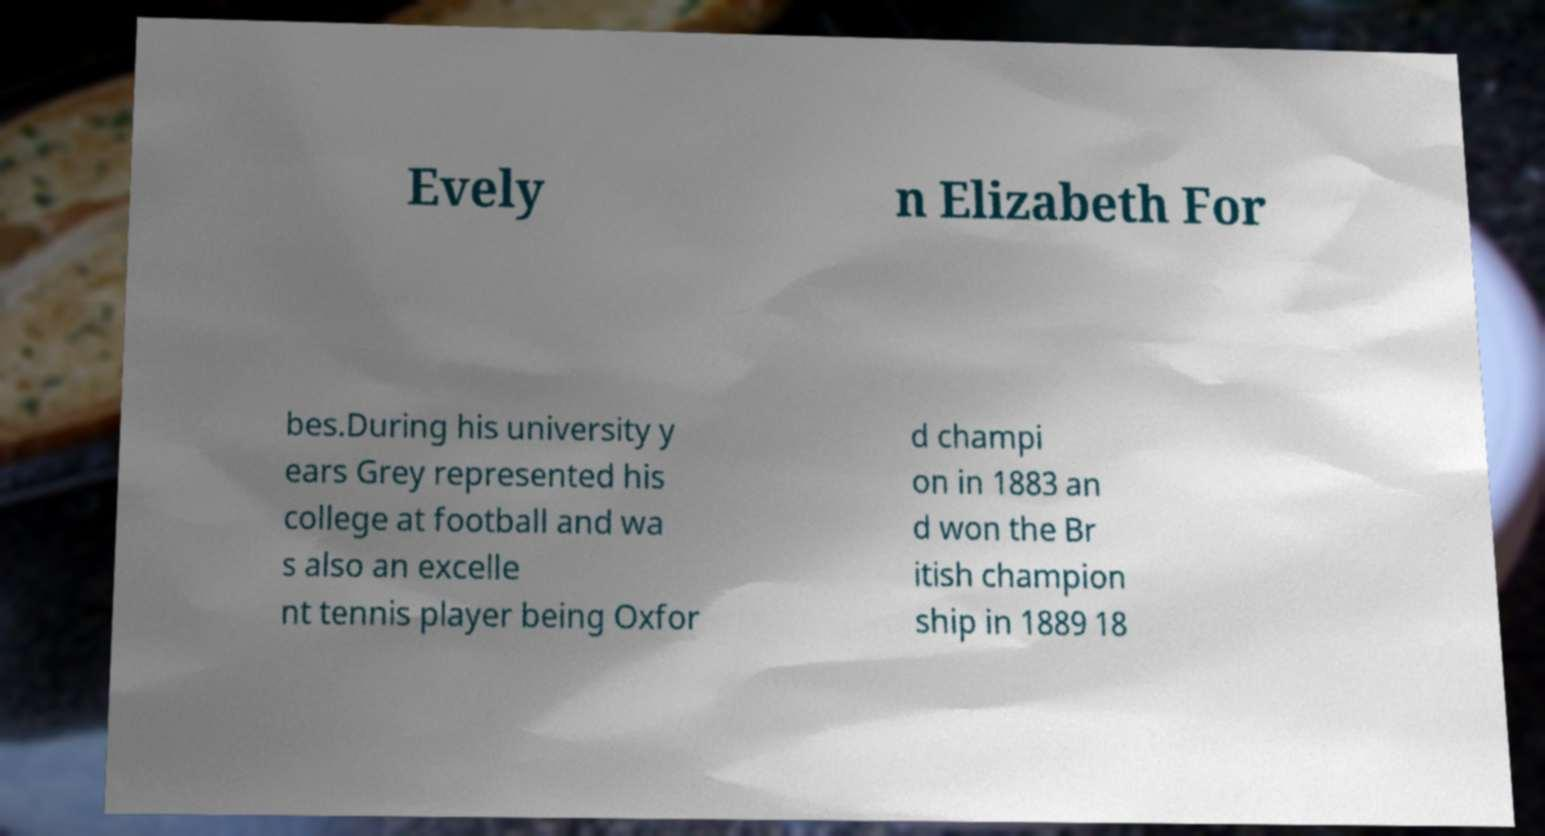Could you assist in decoding the text presented in this image and type it out clearly? Evely n Elizabeth For bes.During his university y ears Grey represented his college at football and wa s also an excelle nt tennis player being Oxfor d champi on in 1883 an d won the Br itish champion ship in 1889 18 